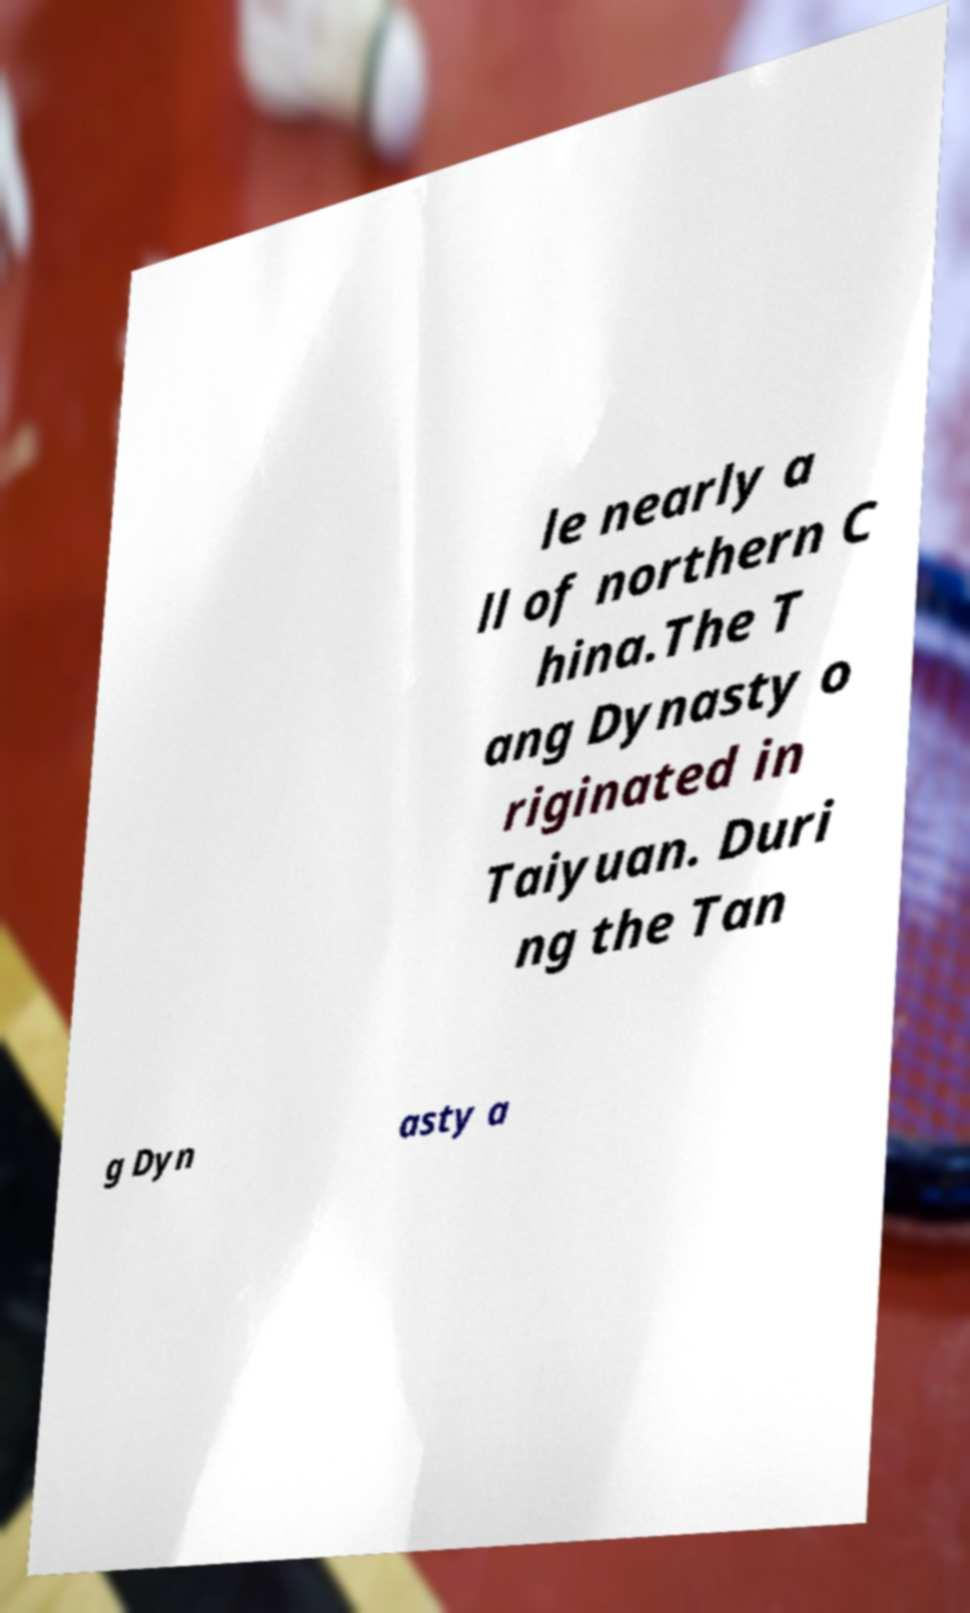Could you assist in decoding the text presented in this image and type it out clearly? le nearly a ll of northern C hina.The T ang Dynasty o riginated in Taiyuan. Duri ng the Tan g Dyn asty a 